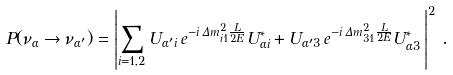<formula> <loc_0><loc_0><loc_500><loc_500>P ( \nu _ { \alpha } \to \nu _ { \alpha ^ { \prime } } ) = \left | \sum _ { i = 1 , 2 } U _ { { \alpha ^ { \prime } } i } \, e ^ { - i \, \Delta { m } ^ { 2 } _ { i 1 } \frac { L } { 2 E } } U _ { { \alpha } i } ^ { * } + U _ { { \alpha ^ { \prime } } 3 } \, e ^ { - i \, \Delta { m } ^ { 2 } _ { 3 1 } \frac { L } { 2 E } } U _ { { \alpha } 3 } ^ { * } \, \right | ^ { 2 } \, .</formula> 